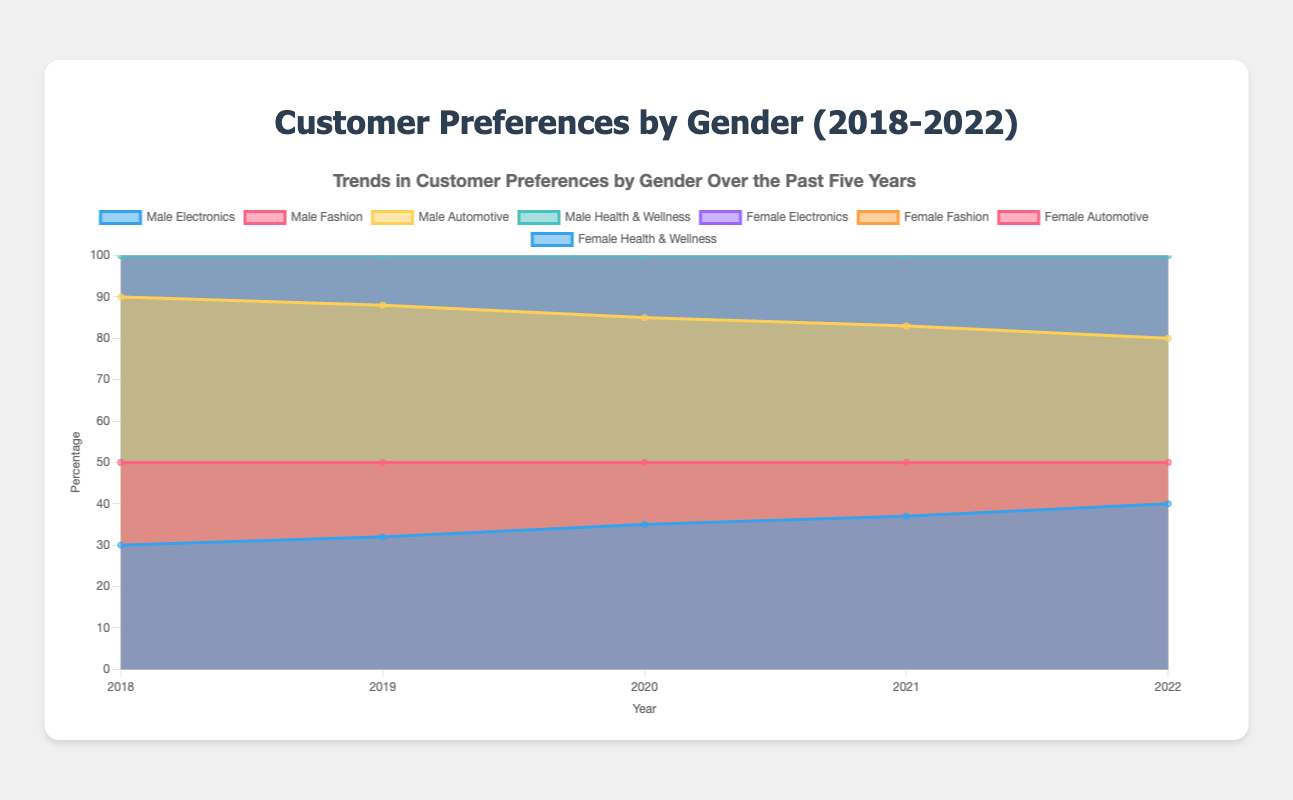What is the overall trend for male interest in electronics from 2018 to 2022? The data for male interest in electronics over the years 2018 to 2022 increases from 30 to 40. This represents a consistent upward trend over the five-year period.
Answer: Increasing Which category had the highest preference among females in 2018? In 2018, the female interest in fashion was at 40%, which is the highest among all categories for females in that year.
Answer: Fashion Compare the trend in automotive preference between males and females over the five years. The male automotive preference shows a slight decrease from 40% to 30%, whereas the female automotive preference shows a slight increase from 10% to 20%.
Answer: Male: Decreasing, Female: Increasing Which year shows the highest overall interest in health and wellness for both genders combined? To find the year with the highest combined interest, sum male and female interest for health and wellness for each year: 2018 (10+30=40), 2019 (12+28=40), 2020 (15+25=40), 2021 (17+23=40), 2022 (20+20=40). All years show the same value of 40.
Answer: All years, 40 By how much did female interest in electronics increase from 2018 to 2022? Female interest in electronics increased from 20% in 2018 to 30% in 2022. The increase is calculated as 30-20=10%.
Answer: 10% Which category shows a decreasing trend over the years for both genders? The category showing a consistent decrease for both genders is fashion, decreasing from 20 to 10 for males and from 40 to 30 for females.
Answer: Fashion What is the difference in male and female interest in health and wellness in 2020? In 2020, male interest in health and wellness is 15% and female interest is 25%. The difference is calculated as 25-15=10%.
Answer: 10% Which category had the highest male preference in 2019 and what was its value? In 2019, the highest male preference is in the automotive category with a value of 38%.
Answer: Automotive, 38% How did female interest in fashion change between 2020 and 2022? Female interest in fashion decreased from 35% in 2020 to 30% in 2022. This represents a decrease of 5%.
Answer: Decrease by 5% What was the average male interest in electronics over the five years? To find the average: (30+32+35+37+40)/5 = 34.8%
Answer: 34.8% 